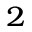<formula> <loc_0><loc_0><loc_500><loc_500>_ { 2 }</formula> 